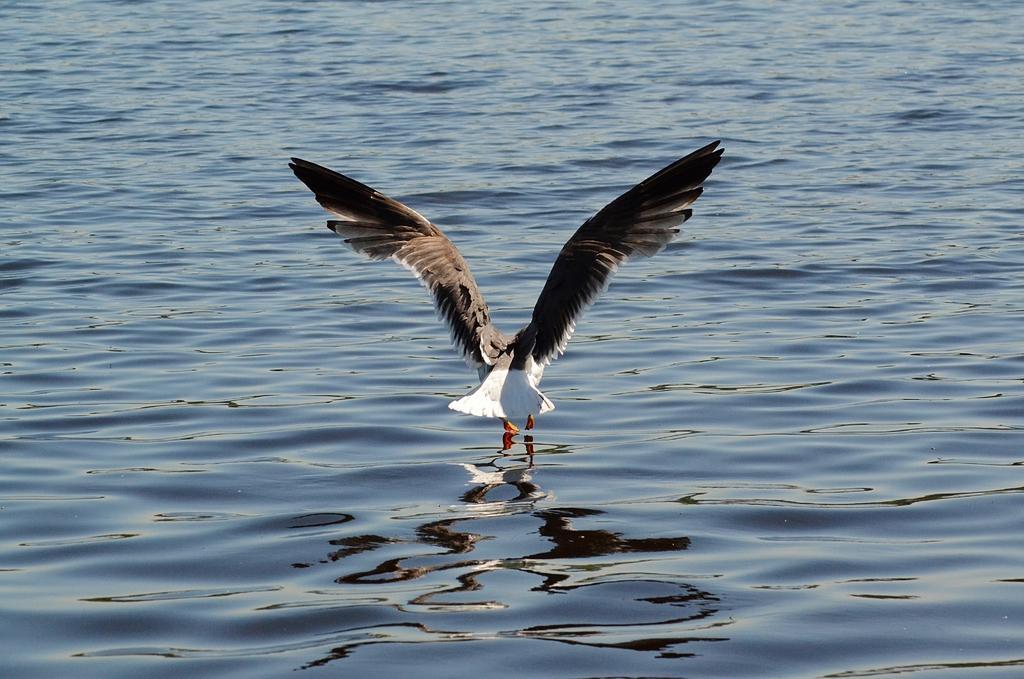Could you give a brief overview of what you see in this image? In the picture i can see a bird which is in white and black color flying and there is water. 